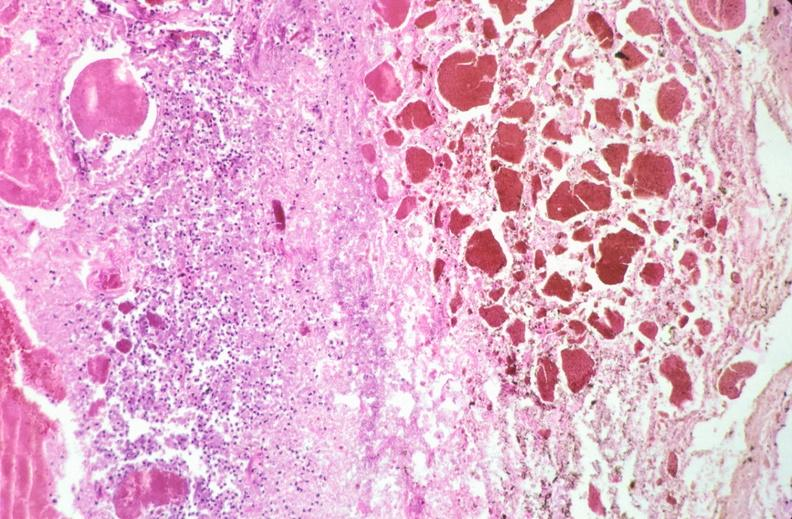what does this image show?
Answer the question using a single word or phrase. Stomach 